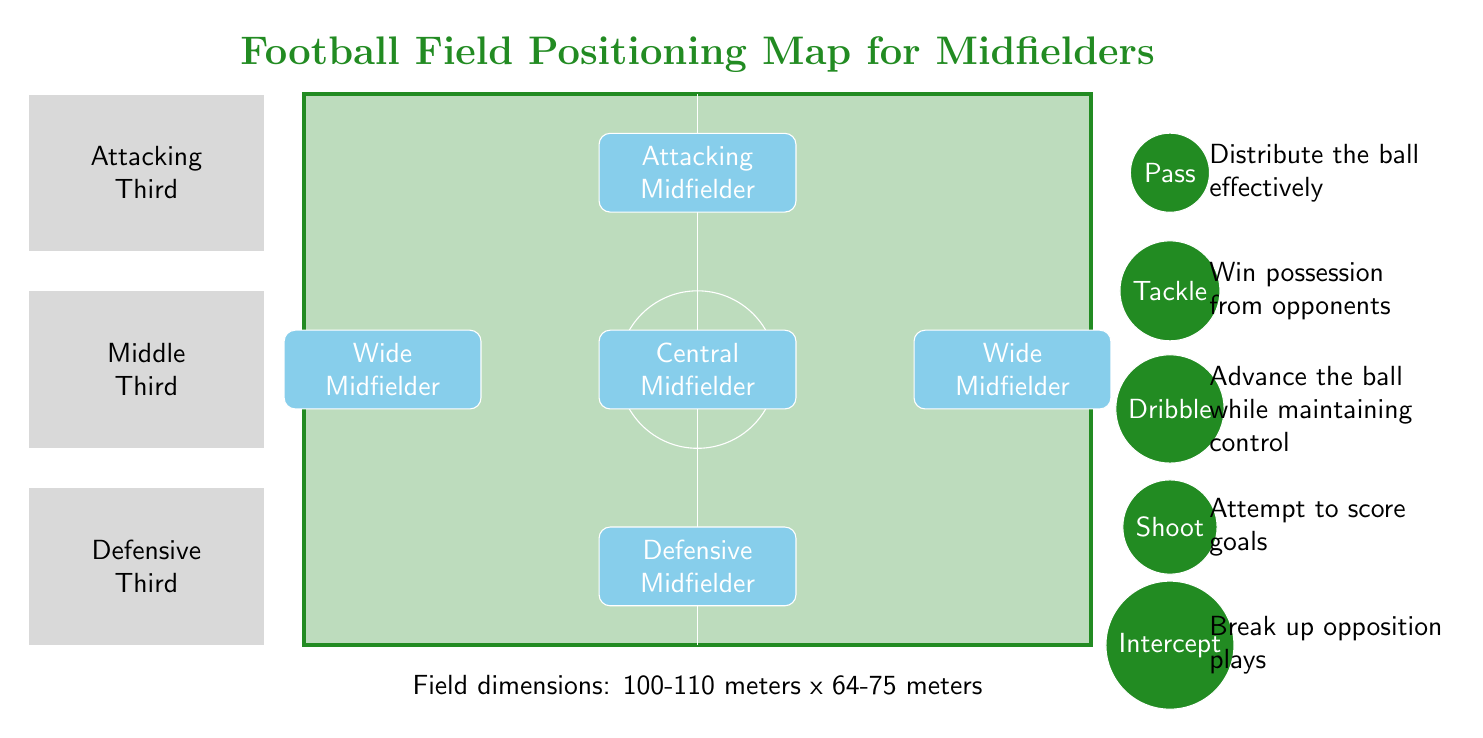What position is located at the center of the field? From the diagram, the position in the center of the field is labeled as "Central Midfielder." This is visually identified by its location at the midpoint of the field, indicating its significance in transitioning between defense and attack.
Answer: Central Midfielder How many midfield positions are depicted in the diagram? The diagram features five distinct midfielder positions: Defensive Midfielder, Central Midfielder, Attacking Midfielder, Wide Midfielder on the left, and Wide Midfielder on the right. Counting them provides the total number of midfielder positions shown.
Answer: 5 What action corresponds to the position of the attacking midfielder? The attacking midfielder position is shown at the top of the diagram. It correlates with the action "Shoot," which is located directly aligned with it on the right side of the field, suggesting this midfielder’s primary objective in the attack.
Answer: Shoot Which third of the field is the defensive midfielder located in? The Defensive Midfielder is situated at the bottom of the diagram, which corresponds to the "Defensive Third." This association is established from the layout that categorizes the field into defensive, middle, and attacking thirds, aligning the position accordingly.
Answer: Defensive Third What is the main action related to intercepting the ball? The action labeled "Intercept" is located at the bottom section of the right side of the diagram. This action directly corresponds to disrupting the opponents' play, which is aligned with the role of midfielders in transitioning defense to attack.
Answer: Intercept Which midfielder is positioned furthest up the field? The position labeled "Attacking Midfielder" is the highest on the diagram, indicating it is furthest up the field. Positioned at the top, this role is usually focused on offensive plays and advancing toward the goal.
Answer: Attacking Midfielder What is the role of the action "Tackle"? The "Tackle" action is illustrated in the diagram as the action taken to win possession from opponents. Its direct association with the Defensive and Central Midfielder positions indicates its strategic importance in regaining control of the ball.
Answer: Win possession from opponents What are the field dimensions mentioned in the diagram? The diagram notes the field dimensions as "100-110 meters x 64-75 meters." This specification describes the typical size range for a football field, which is important for understanding the playing environment and tactical positioning.
Answer: 100-110 meters x 64-75 meters 